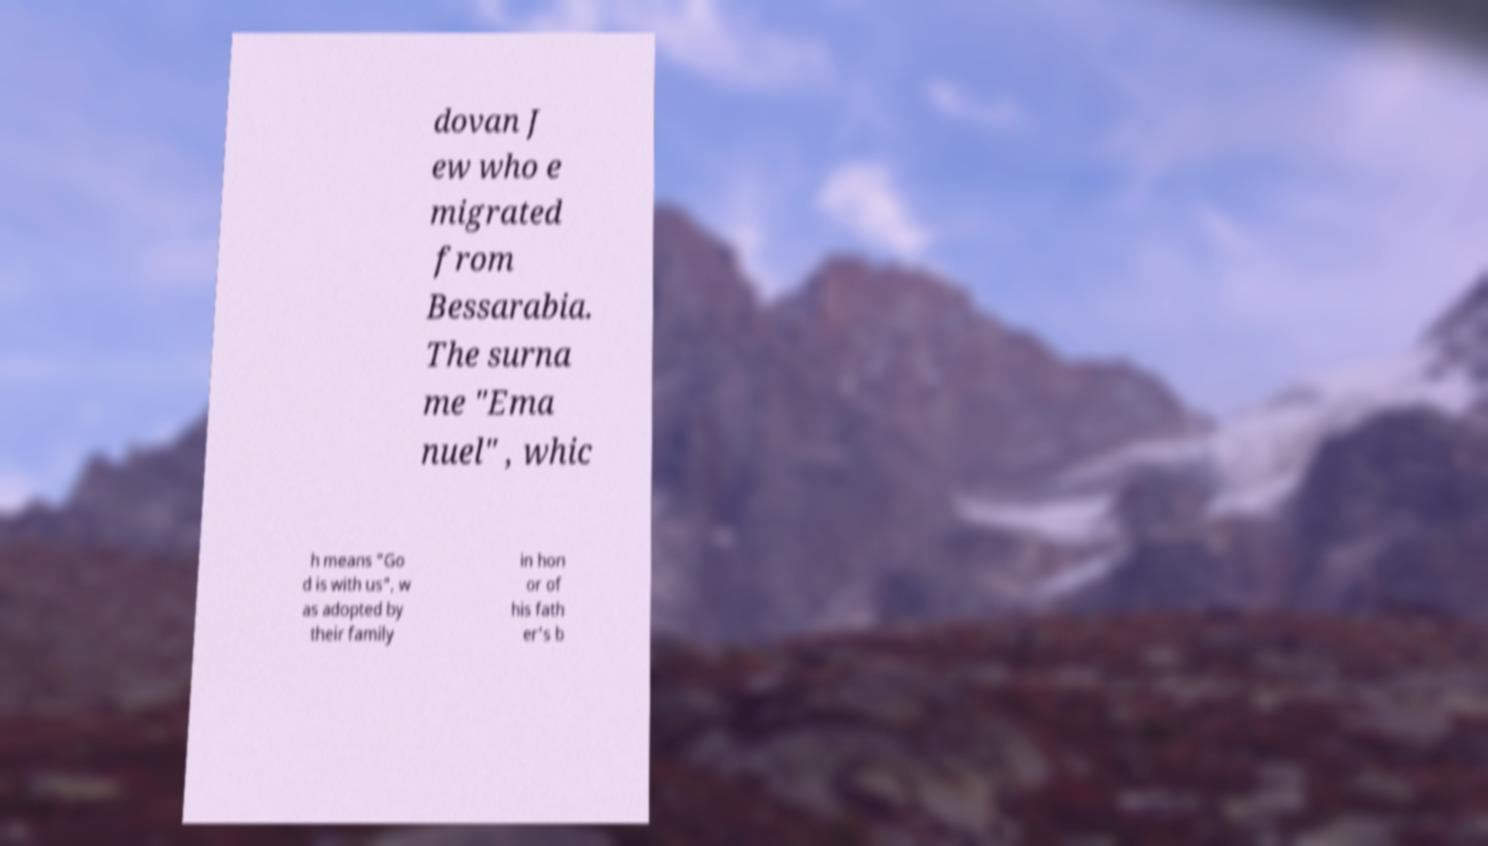I need the written content from this picture converted into text. Can you do that? dovan J ew who e migrated from Bessarabia. The surna me "Ema nuel" , whic h means "Go d is with us", w as adopted by their family in hon or of his fath er's b 